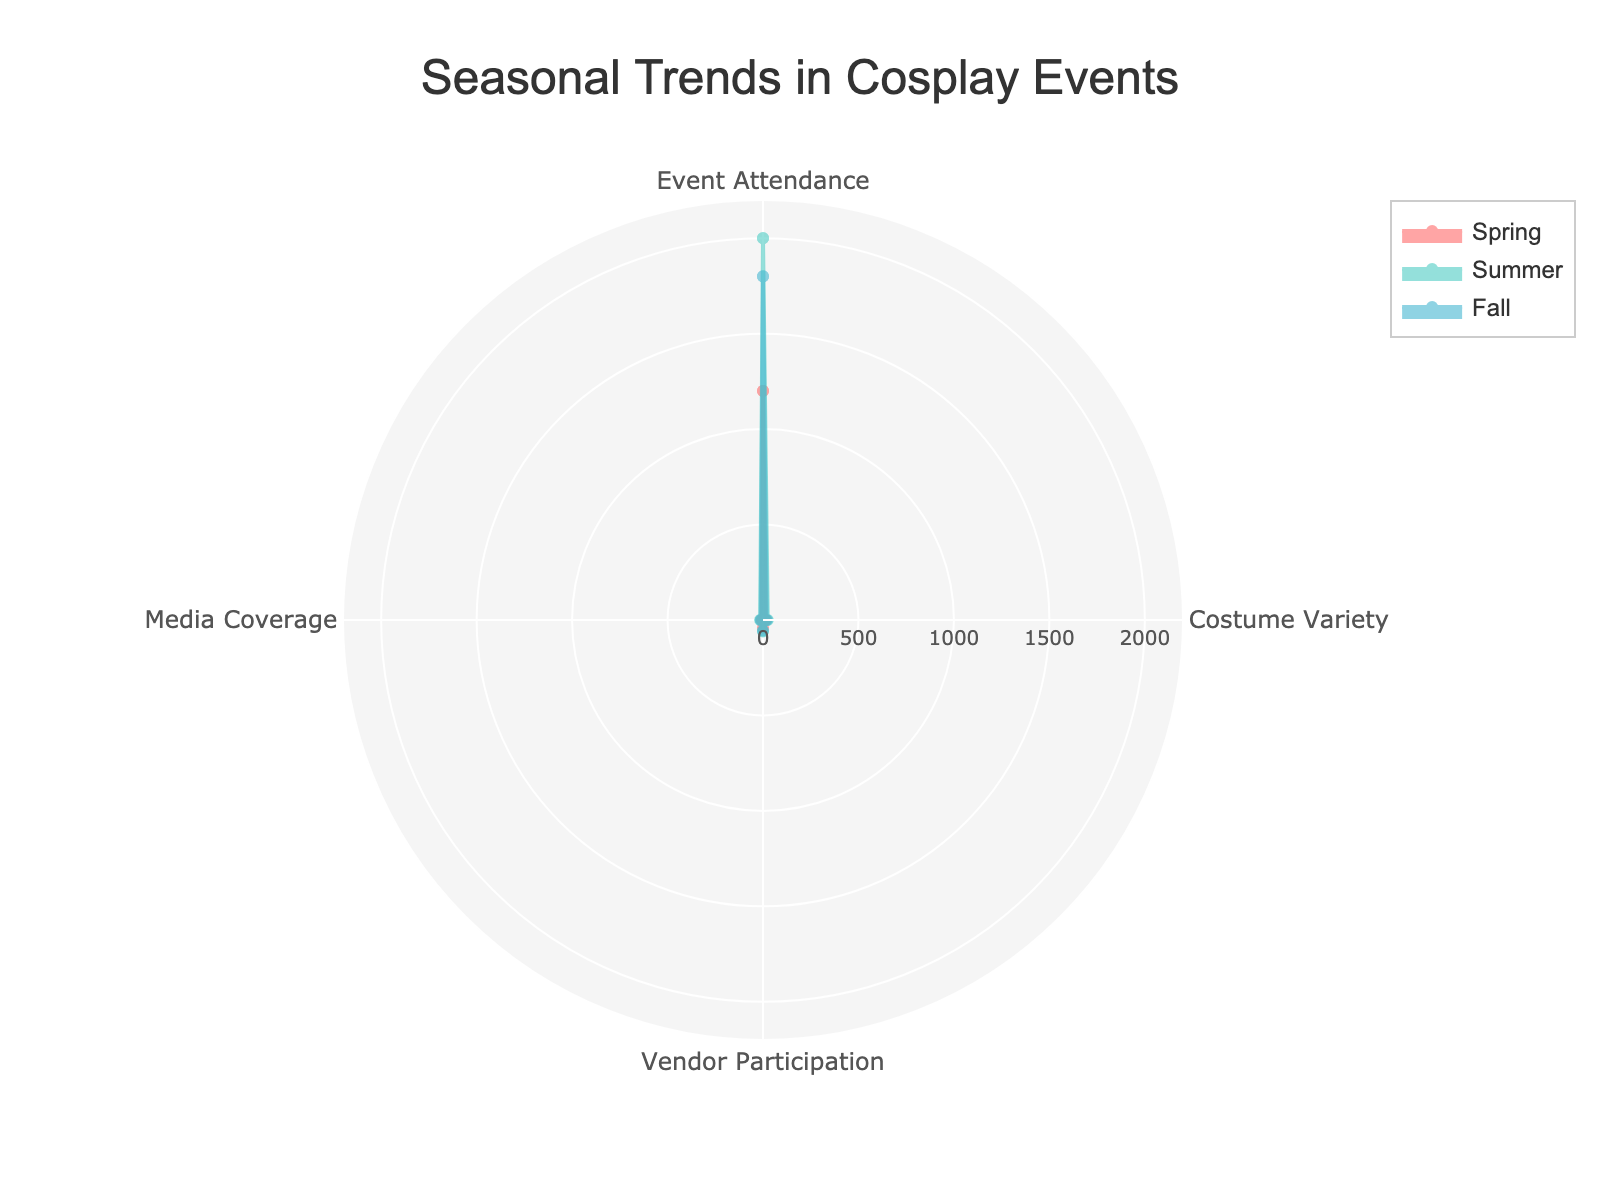How many seasonal groups are represented in the chart? The chart is divided into segments by different colors, each representing a season. By observing the number of distinct colored sections, we identify three groups: Spring, Summer, and Fall.
Answer: Three Which season has the highest event attendance? Event attendance can be observed from the outermost extent of each segment in the radar chart. The section that extends furthest represents Summer with 2000 attendees.
Answer: Summer Which category has the highest value in the chart, and for which season? By looking for the longest radial line among all categories, we identify Event Attendance during Summer as the highest at 2000.
Answer: Event Attendance during Summer What is the total number of vendors participating across all seasons? Summing the values for Vendor Participation across Spring, Summer, and Fall gives 40 + 60 + 55 = 155.
Answer: 155 Compare the media coverage between Fall and Spring. Which one is higher and by how much? Comparing the radial values for Media Coverage between Fall (12) and Spring (7), we calculate the difference: 12 - 7 = 5, indicating Fall has higher media coverage by 5 units.
Answer: Fall, by 5 Which category shows the least variation across the seasons? Least variation can be identified by looking for the category with the smallest difference between maximum and minimum values. Costume Variety varies from 15 in Spring to 25 in Summer (a difference of 10). Other categories have higher variations.
Answer: Costume Variety What is the average number of event attendees across all seasons? Summing the event attendances for Spring (1200), Summer (2000), and Fall (1800) gives 5000. Dividing 5000 by 3 seasons results in an average of 1666.67 attendees.
Answer: 1666.67 How does vendor participation in Spring compare to Costume Variety in Fall? Observing the radial values, Vendor Participation in Spring is 40, and Costume Variety in Fall is 20. Thus, vendor participation in Spring is double the Costume Variety in Fall.
Answer: Spring has double the value 